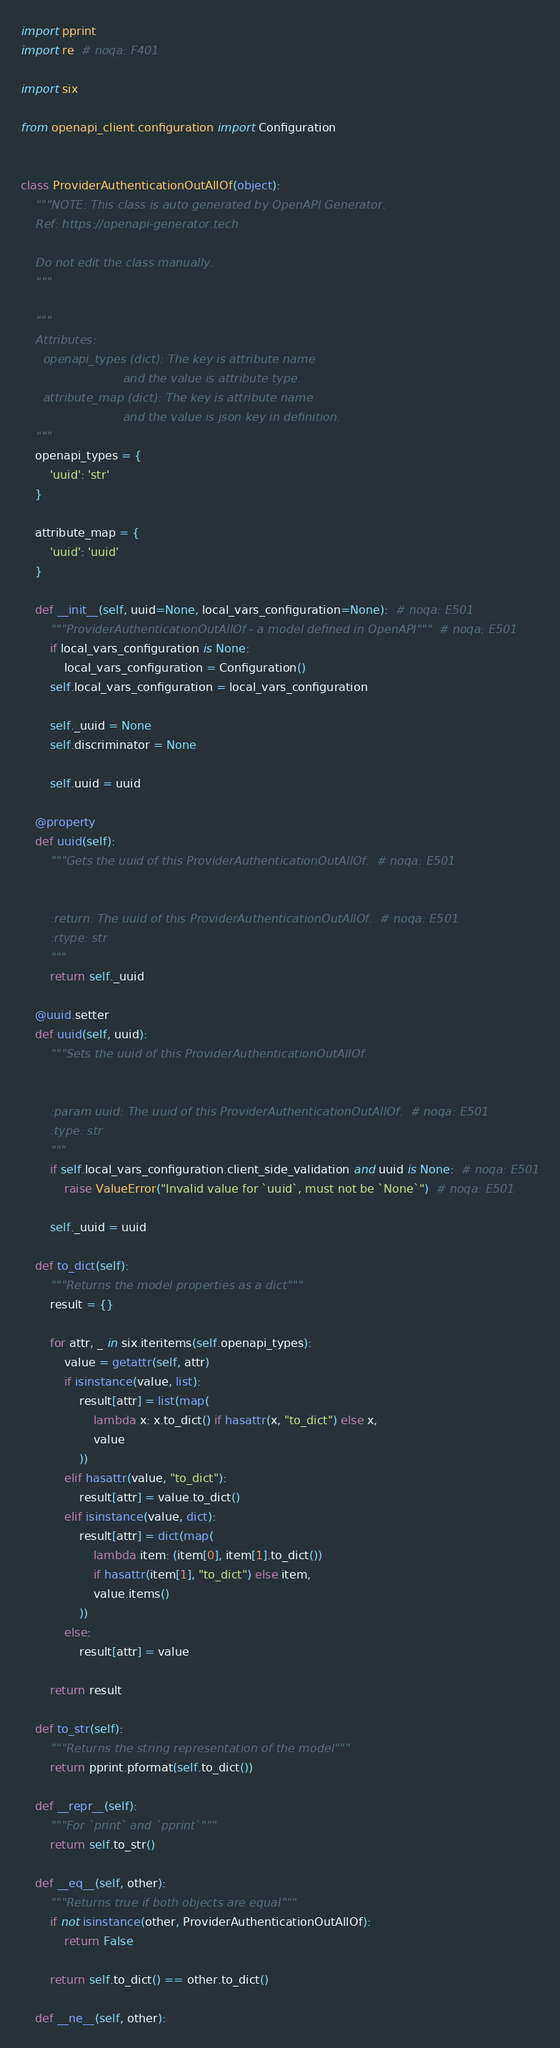Convert code to text. <code><loc_0><loc_0><loc_500><loc_500><_Python_>
import pprint
import re  # noqa: F401

import six

from openapi_client.configuration import Configuration


class ProviderAuthenticationOutAllOf(object):
    """NOTE: This class is auto generated by OpenAPI Generator.
    Ref: https://openapi-generator.tech

    Do not edit the class manually.
    """

    """
    Attributes:
      openapi_types (dict): The key is attribute name
                            and the value is attribute type.
      attribute_map (dict): The key is attribute name
                            and the value is json key in definition.
    """
    openapi_types = {
        'uuid': 'str'
    }

    attribute_map = {
        'uuid': 'uuid'
    }

    def __init__(self, uuid=None, local_vars_configuration=None):  # noqa: E501
        """ProviderAuthenticationOutAllOf - a model defined in OpenAPI"""  # noqa: E501
        if local_vars_configuration is None:
            local_vars_configuration = Configuration()
        self.local_vars_configuration = local_vars_configuration

        self._uuid = None
        self.discriminator = None

        self.uuid = uuid

    @property
    def uuid(self):
        """Gets the uuid of this ProviderAuthenticationOutAllOf.  # noqa: E501


        :return: The uuid of this ProviderAuthenticationOutAllOf.  # noqa: E501
        :rtype: str
        """
        return self._uuid

    @uuid.setter
    def uuid(self, uuid):
        """Sets the uuid of this ProviderAuthenticationOutAllOf.


        :param uuid: The uuid of this ProviderAuthenticationOutAllOf.  # noqa: E501
        :type: str
        """
        if self.local_vars_configuration.client_side_validation and uuid is None:  # noqa: E501
            raise ValueError("Invalid value for `uuid`, must not be `None`")  # noqa: E501

        self._uuid = uuid

    def to_dict(self):
        """Returns the model properties as a dict"""
        result = {}

        for attr, _ in six.iteritems(self.openapi_types):
            value = getattr(self, attr)
            if isinstance(value, list):
                result[attr] = list(map(
                    lambda x: x.to_dict() if hasattr(x, "to_dict") else x,
                    value
                ))
            elif hasattr(value, "to_dict"):
                result[attr] = value.to_dict()
            elif isinstance(value, dict):
                result[attr] = dict(map(
                    lambda item: (item[0], item[1].to_dict())
                    if hasattr(item[1], "to_dict") else item,
                    value.items()
                ))
            else:
                result[attr] = value

        return result

    def to_str(self):
        """Returns the string representation of the model"""
        return pprint.pformat(self.to_dict())

    def __repr__(self):
        """For `print` and `pprint`"""
        return self.to_str()

    def __eq__(self, other):
        """Returns true if both objects are equal"""
        if not isinstance(other, ProviderAuthenticationOutAllOf):
            return False

        return self.to_dict() == other.to_dict()

    def __ne__(self, other):</code> 